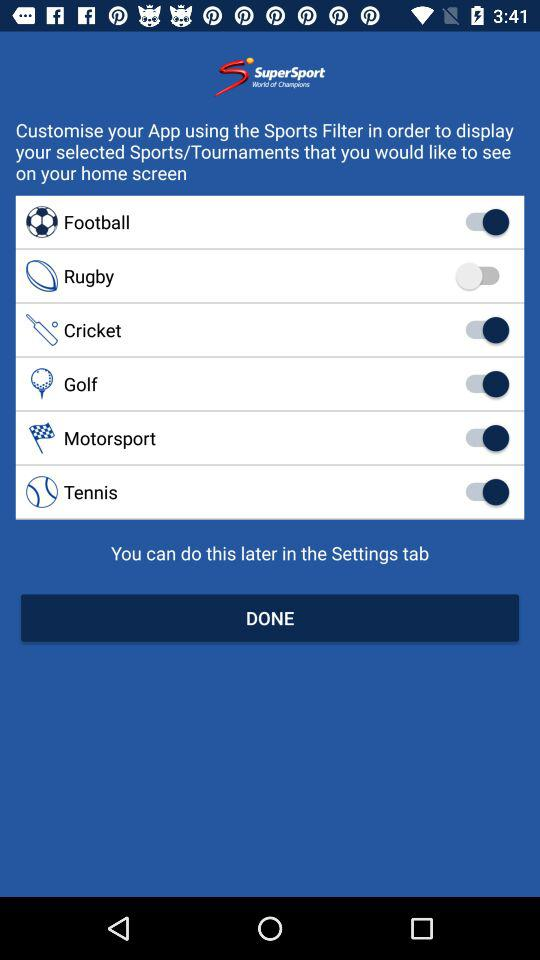What is the status of "Rugby"? The status is "off". 